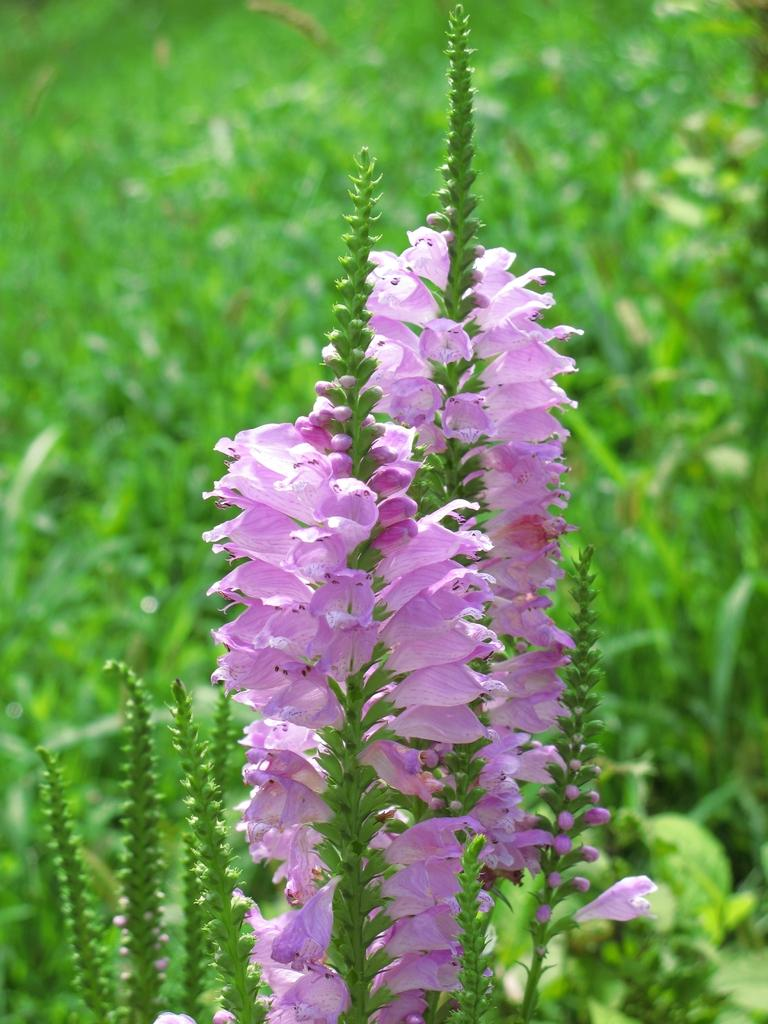What is the primary subject of the image? The primary subject of the image is plants. Can you describe the plants in the foreground? In the foreground, there are stems with flowers and buds. What type of fuel is being used by the plants in the image? There is no mention of fuel in the image, as plants typically produce their own energy through photosynthesis. 